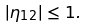Convert formula to latex. <formula><loc_0><loc_0><loc_500><loc_500>| \eta _ { 1 2 } | \leq 1 .</formula> 